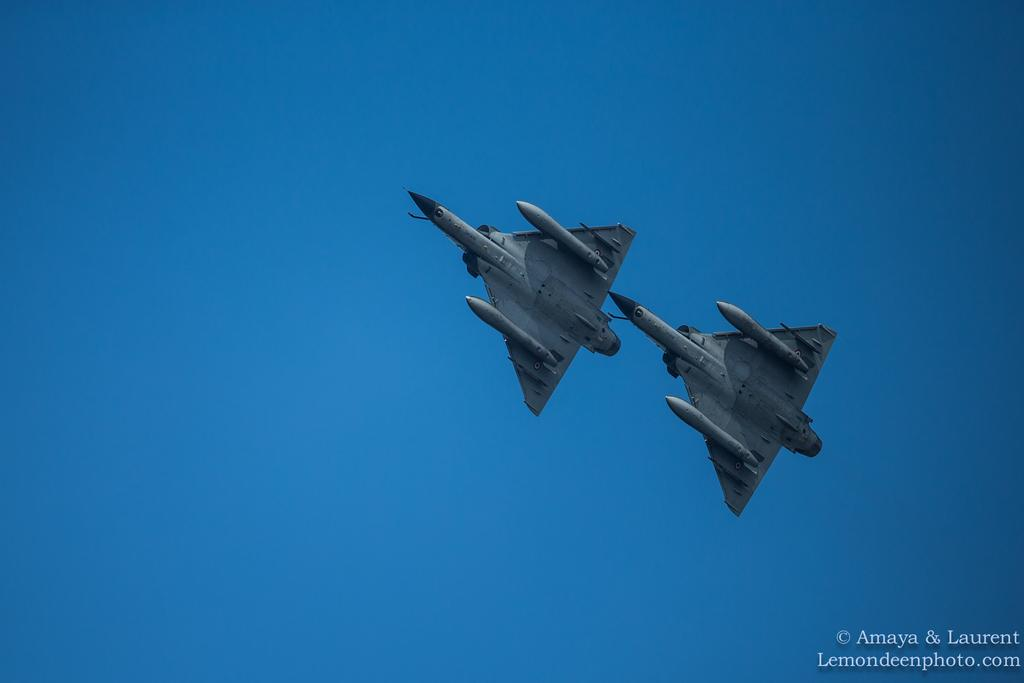<image>
Give a short and clear explanation of the subsequent image. two planes flying next to each other in the sky by amaya and laurent 